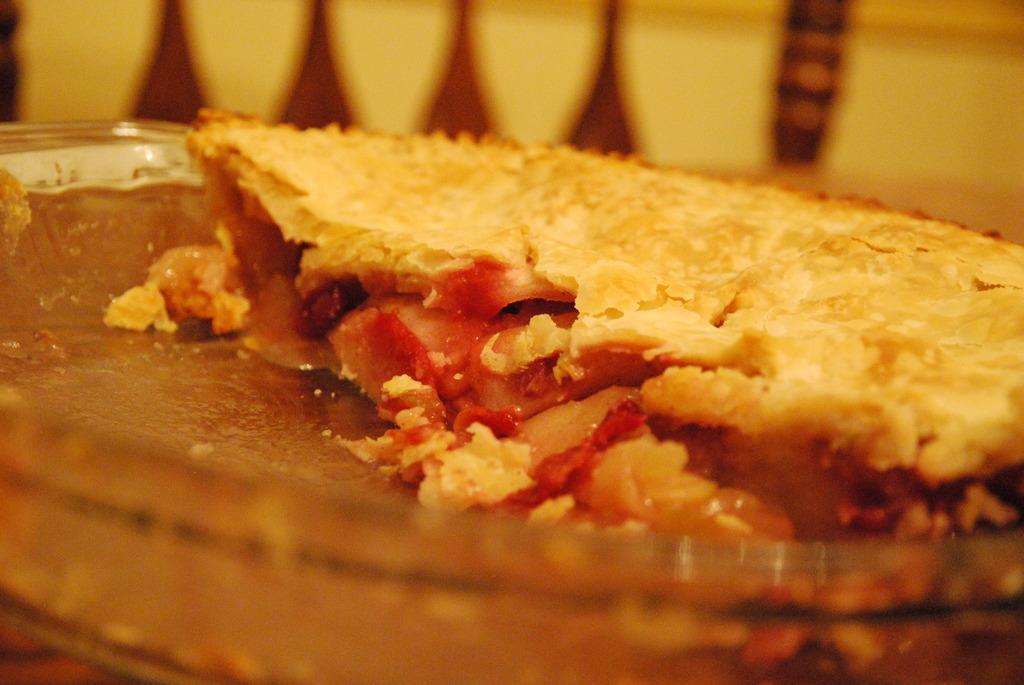Describe this image in one or two sentences. In this image, I can see a food item on the glass plate. The background looks yellow and brown in color. 